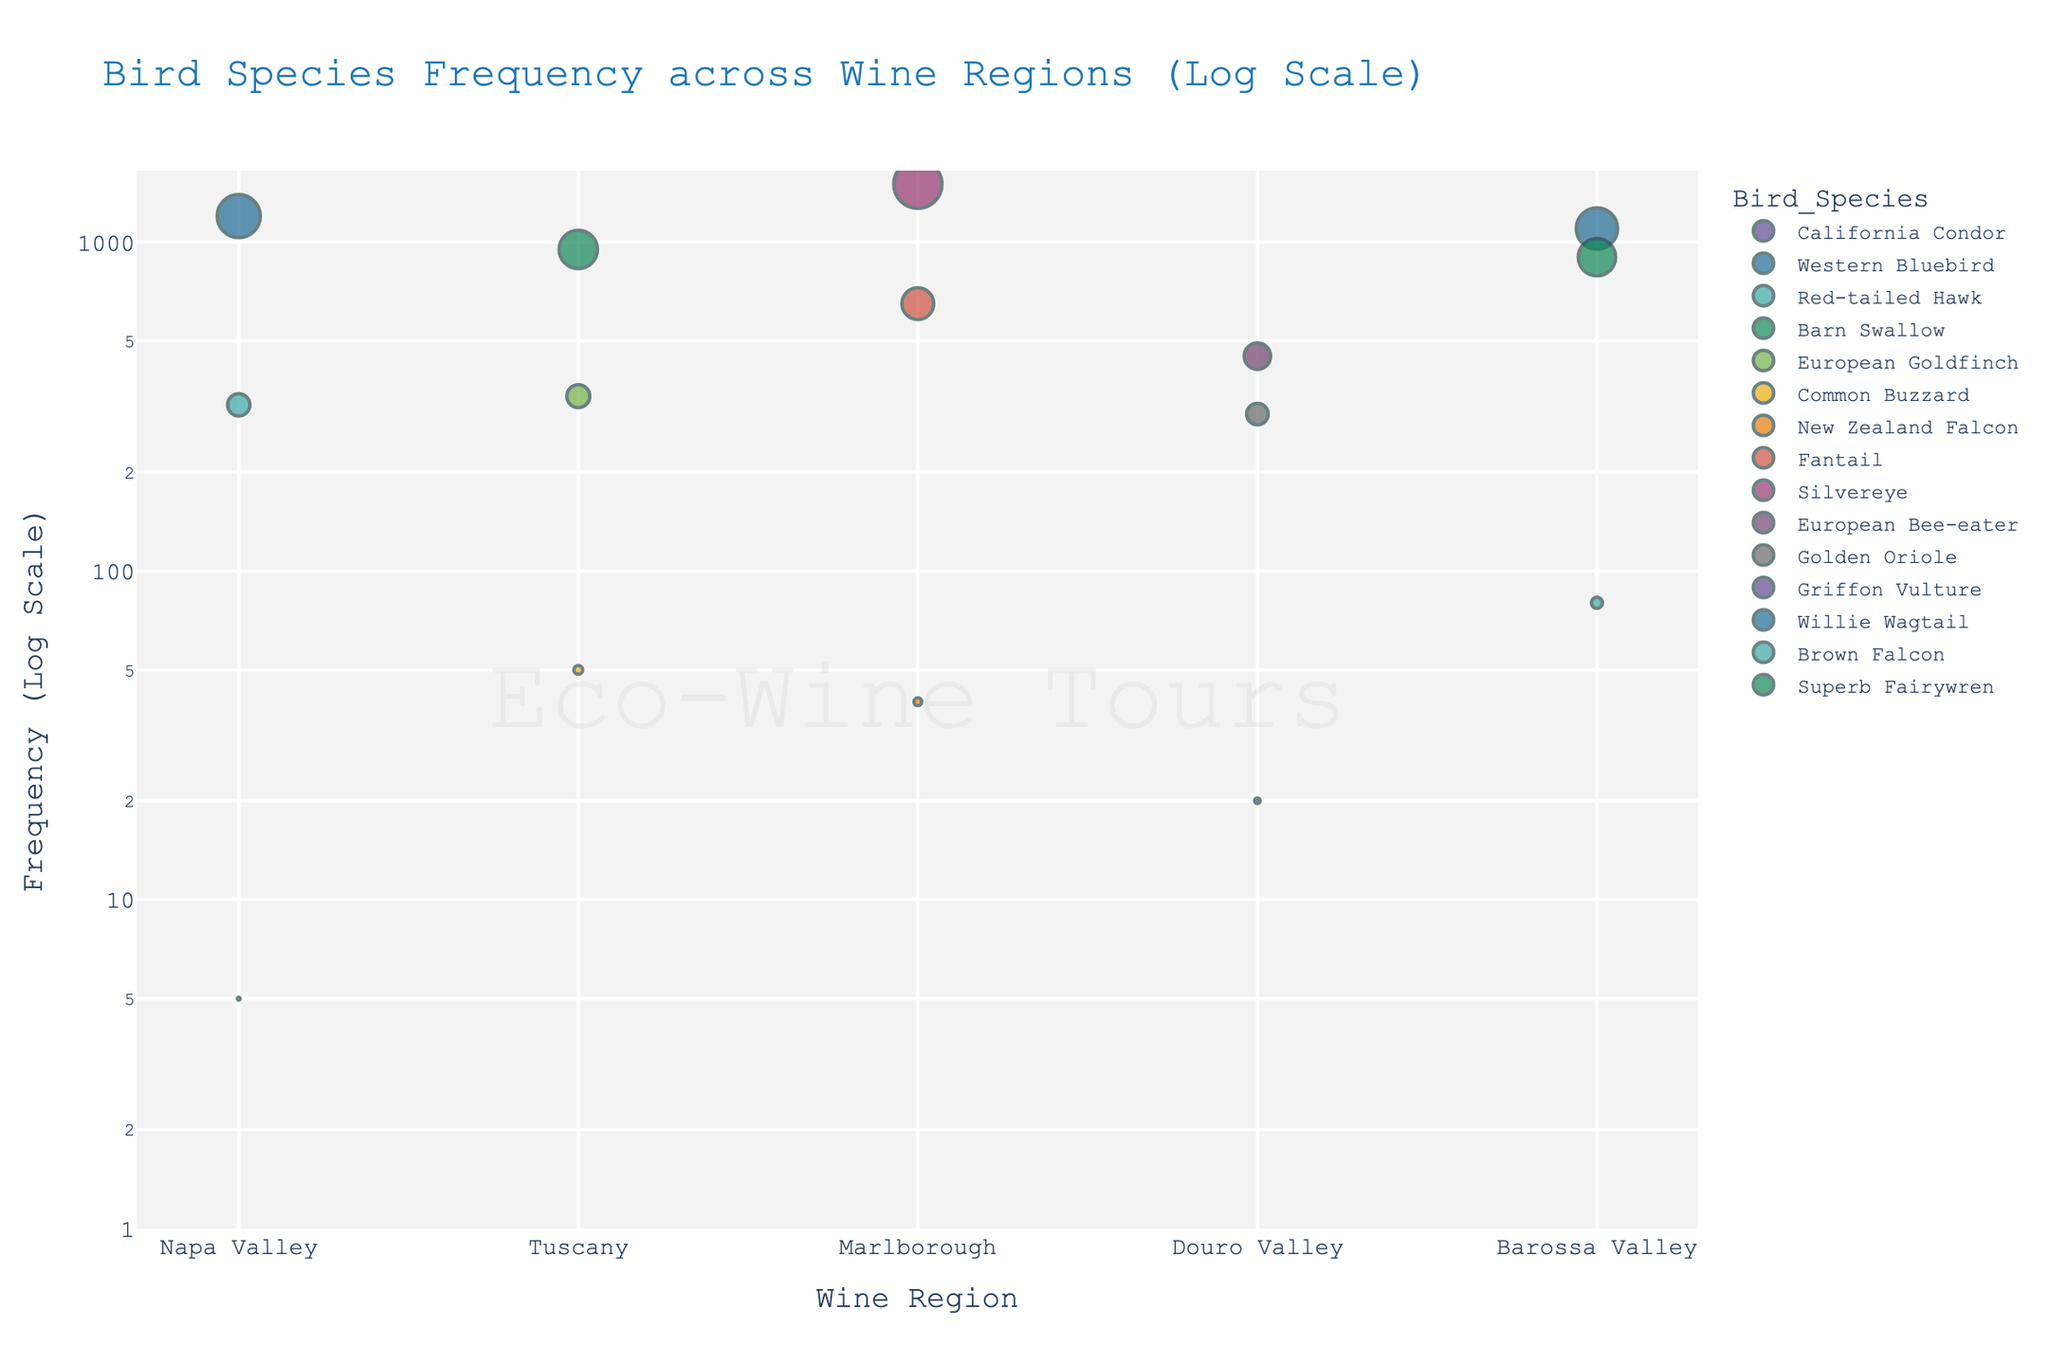What's the most frequent bird species spotted in the Napa Valley? To determine this, observe the bird species in the Napa Valley on the x-axis and compare their frequencies. Western Bluebird has the highest frequency with a bubble size representing 1200 in the log scale.
Answer: Western Bluebird Which region has the lowest frequency of any bird species, and what species is it? Check the smallest bubble in the plot, which represents the lowest frequency. The smallest bubble is for the California Condor in Napa Valley with a frequency of 5 on the log scale.
Answer: Napa Valley, California Condor What's the combined frequency of the Fantail and Silvereye in Marlborough? Add the frequencies of the Fantail (650) and Silvereye (1500) in the Marlborough region. 650 + 1500 = 2150.
Answer: 2150 Compare the frequency of the Willie Wagtail in Barossa Valley to the European Bee-eater in Douro Valley. Which is higher? Observe the sizes of the bubbles for both species in their respective regions. The Willie Wagtail in Barossa Valley has a higher frequency (1100) compared to the European Bee-eater in Douro Valley (450).
Answer: Willie Wagtail What's the average frequency of all bird species in Tuscany? Calculate the total frequency for all bird species in Tuscany: Barn Swallow (950) + European Goldfinch (340) + Common Buzzard (50) = 1340. Then divide by the number of species (3): 1340/3 ≈ 447.
Answer: Approximately 447 Which bird species in Douro Valley has the lowest frequency? Look at the bubbles representing bird species in Douro Valley and identify the smallest one. The Griffon Vulture has the lowest frequency with a value of 20.
Answer: Griffon Vulture How does the frequency of the Common Buzzard in Tuscany compare to the Brown Falcon in Barossa Valley? Compare the sizes of the bubbles representing the Common Buzzard (50) in Tuscany and the Brown Falcon (80) in Barossa Valley. The Brown Falcon has a higher frequency than the Common Buzzard.
Answer: Brown Falcon has a higher frequency What is the total number of bird species recorded across all regions? Count the number of unique bird species listed in the plot. There are 15 unique bird species.
Answer: 15 Which wine region has the highest total frequency of birds? Sum the frequencies of all bird species in each region. The region with the highest total will be the answer. After summing, Marlborough has the highest total frequency: 40 (New Zealand Falcon) + 650 (Fantail) + 1500 (Silvereye) = 2190.
Answer: Marlborough 